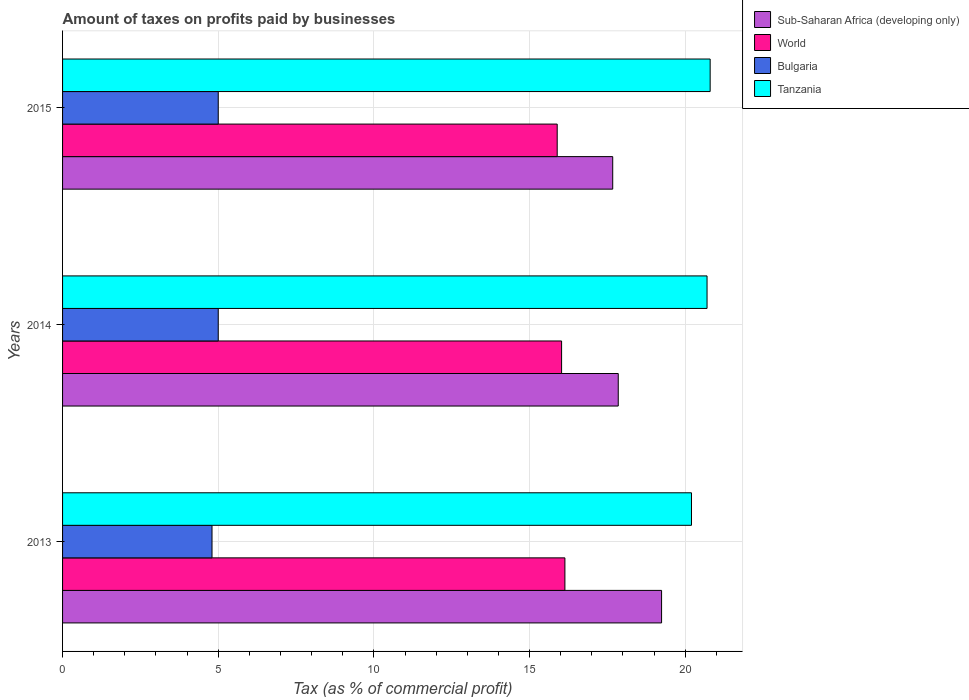Are the number of bars per tick equal to the number of legend labels?
Provide a succinct answer. Yes. How many bars are there on the 2nd tick from the top?
Keep it short and to the point. 4. How many bars are there on the 3rd tick from the bottom?
Offer a very short reply. 4. What is the label of the 1st group of bars from the top?
Ensure brevity in your answer.  2015. What is the percentage of taxes paid by businesses in Sub-Saharan Africa (developing only) in 2013?
Your answer should be very brief. 19.24. Across all years, what is the maximum percentage of taxes paid by businesses in World?
Provide a short and direct response. 16.13. Across all years, what is the minimum percentage of taxes paid by businesses in Bulgaria?
Your answer should be compact. 4.8. In which year was the percentage of taxes paid by businesses in World maximum?
Offer a terse response. 2013. In which year was the percentage of taxes paid by businesses in Sub-Saharan Africa (developing only) minimum?
Make the answer very short. 2015. What is the total percentage of taxes paid by businesses in Tanzania in the graph?
Offer a terse response. 61.7. What is the difference between the percentage of taxes paid by businesses in Bulgaria in 2013 and that in 2014?
Ensure brevity in your answer.  -0.2. What is the difference between the percentage of taxes paid by businesses in Tanzania in 2014 and the percentage of taxes paid by businesses in World in 2013?
Offer a very short reply. 4.57. What is the average percentage of taxes paid by businesses in Bulgaria per year?
Keep it short and to the point. 4.93. In the year 2015, what is the difference between the percentage of taxes paid by businesses in Sub-Saharan Africa (developing only) and percentage of taxes paid by businesses in Bulgaria?
Your response must be concise. 12.67. In how many years, is the percentage of taxes paid by businesses in Bulgaria greater than 14 %?
Provide a succinct answer. 0. What is the ratio of the percentage of taxes paid by businesses in Tanzania in 2013 to that in 2014?
Your answer should be compact. 0.98. Is the percentage of taxes paid by businesses in World in 2014 less than that in 2015?
Provide a succinct answer. No. What is the difference between the highest and the second highest percentage of taxes paid by businesses in Tanzania?
Give a very brief answer. 0.1. What is the difference between the highest and the lowest percentage of taxes paid by businesses in Sub-Saharan Africa (developing only)?
Provide a succinct answer. 1.57. Is the sum of the percentage of taxes paid by businesses in Sub-Saharan Africa (developing only) in 2013 and 2014 greater than the maximum percentage of taxes paid by businesses in World across all years?
Your response must be concise. Yes. Is it the case that in every year, the sum of the percentage of taxes paid by businesses in Bulgaria and percentage of taxes paid by businesses in Tanzania is greater than the sum of percentage of taxes paid by businesses in World and percentage of taxes paid by businesses in Sub-Saharan Africa (developing only)?
Your answer should be very brief. Yes. What does the 2nd bar from the top in 2013 represents?
Ensure brevity in your answer.  Bulgaria. Are all the bars in the graph horizontal?
Your answer should be very brief. Yes. How many years are there in the graph?
Ensure brevity in your answer.  3. Are the values on the major ticks of X-axis written in scientific E-notation?
Your answer should be very brief. No. Does the graph contain any zero values?
Provide a short and direct response. No. How are the legend labels stacked?
Offer a terse response. Vertical. What is the title of the graph?
Your response must be concise. Amount of taxes on profits paid by businesses. What is the label or title of the X-axis?
Your response must be concise. Tax (as % of commercial profit). What is the Tax (as % of commercial profit) of Sub-Saharan Africa (developing only) in 2013?
Your response must be concise. 19.24. What is the Tax (as % of commercial profit) in World in 2013?
Provide a succinct answer. 16.13. What is the Tax (as % of commercial profit) of Tanzania in 2013?
Give a very brief answer. 20.2. What is the Tax (as % of commercial profit) in Sub-Saharan Africa (developing only) in 2014?
Provide a succinct answer. 17.85. What is the Tax (as % of commercial profit) in World in 2014?
Provide a succinct answer. 16.03. What is the Tax (as % of commercial profit) of Tanzania in 2014?
Your answer should be compact. 20.7. What is the Tax (as % of commercial profit) in Sub-Saharan Africa (developing only) in 2015?
Give a very brief answer. 17.67. What is the Tax (as % of commercial profit) in World in 2015?
Your answer should be compact. 15.89. What is the Tax (as % of commercial profit) of Tanzania in 2015?
Keep it short and to the point. 20.8. Across all years, what is the maximum Tax (as % of commercial profit) in Sub-Saharan Africa (developing only)?
Provide a short and direct response. 19.24. Across all years, what is the maximum Tax (as % of commercial profit) of World?
Offer a terse response. 16.13. Across all years, what is the maximum Tax (as % of commercial profit) in Tanzania?
Provide a succinct answer. 20.8. Across all years, what is the minimum Tax (as % of commercial profit) of Sub-Saharan Africa (developing only)?
Make the answer very short. 17.67. Across all years, what is the minimum Tax (as % of commercial profit) in World?
Your answer should be very brief. 15.89. Across all years, what is the minimum Tax (as % of commercial profit) of Bulgaria?
Your response must be concise. 4.8. Across all years, what is the minimum Tax (as % of commercial profit) in Tanzania?
Your answer should be very brief. 20.2. What is the total Tax (as % of commercial profit) of Sub-Saharan Africa (developing only) in the graph?
Give a very brief answer. 54.76. What is the total Tax (as % of commercial profit) in World in the graph?
Offer a very short reply. 48.05. What is the total Tax (as % of commercial profit) of Tanzania in the graph?
Your answer should be very brief. 61.7. What is the difference between the Tax (as % of commercial profit) in Sub-Saharan Africa (developing only) in 2013 and that in 2014?
Ensure brevity in your answer.  1.39. What is the difference between the Tax (as % of commercial profit) of World in 2013 and that in 2014?
Your answer should be compact. 0.11. What is the difference between the Tax (as % of commercial profit) in Tanzania in 2013 and that in 2014?
Provide a short and direct response. -0.5. What is the difference between the Tax (as % of commercial profit) of Sub-Saharan Africa (developing only) in 2013 and that in 2015?
Offer a very short reply. 1.57. What is the difference between the Tax (as % of commercial profit) in World in 2013 and that in 2015?
Make the answer very short. 0.25. What is the difference between the Tax (as % of commercial profit) of Sub-Saharan Africa (developing only) in 2014 and that in 2015?
Give a very brief answer. 0.18. What is the difference between the Tax (as % of commercial profit) in World in 2014 and that in 2015?
Your answer should be very brief. 0.14. What is the difference between the Tax (as % of commercial profit) of Bulgaria in 2014 and that in 2015?
Keep it short and to the point. 0. What is the difference between the Tax (as % of commercial profit) in Tanzania in 2014 and that in 2015?
Offer a very short reply. -0.1. What is the difference between the Tax (as % of commercial profit) of Sub-Saharan Africa (developing only) in 2013 and the Tax (as % of commercial profit) of World in 2014?
Ensure brevity in your answer.  3.21. What is the difference between the Tax (as % of commercial profit) in Sub-Saharan Africa (developing only) in 2013 and the Tax (as % of commercial profit) in Bulgaria in 2014?
Ensure brevity in your answer.  14.24. What is the difference between the Tax (as % of commercial profit) in Sub-Saharan Africa (developing only) in 2013 and the Tax (as % of commercial profit) in Tanzania in 2014?
Your answer should be very brief. -1.46. What is the difference between the Tax (as % of commercial profit) in World in 2013 and the Tax (as % of commercial profit) in Bulgaria in 2014?
Your answer should be compact. 11.13. What is the difference between the Tax (as % of commercial profit) of World in 2013 and the Tax (as % of commercial profit) of Tanzania in 2014?
Your response must be concise. -4.57. What is the difference between the Tax (as % of commercial profit) in Bulgaria in 2013 and the Tax (as % of commercial profit) in Tanzania in 2014?
Offer a very short reply. -15.9. What is the difference between the Tax (as % of commercial profit) of Sub-Saharan Africa (developing only) in 2013 and the Tax (as % of commercial profit) of World in 2015?
Your answer should be compact. 3.35. What is the difference between the Tax (as % of commercial profit) of Sub-Saharan Africa (developing only) in 2013 and the Tax (as % of commercial profit) of Bulgaria in 2015?
Provide a short and direct response. 14.24. What is the difference between the Tax (as % of commercial profit) of Sub-Saharan Africa (developing only) in 2013 and the Tax (as % of commercial profit) of Tanzania in 2015?
Your answer should be compact. -1.56. What is the difference between the Tax (as % of commercial profit) of World in 2013 and the Tax (as % of commercial profit) of Bulgaria in 2015?
Your answer should be compact. 11.13. What is the difference between the Tax (as % of commercial profit) in World in 2013 and the Tax (as % of commercial profit) in Tanzania in 2015?
Keep it short and to the point. -4.67. What is the difference between the Tax (as % of commercial profit) in Bulgaria in 2013 and the Tax (as % of commercial profit) in Tanzania in 2015?
Keep it short and to the point. -16. What is the difference between the Tax (as % of commercial profit) of Sub-Saharan Africa (developing only) in 2014 and the Tax (as % of commercial profit) of World in 2015?
Offer a very short reply. 1.96. What is the difference between the Tax (as % of commercial profit) in Sub-Saharan Africa (developing only) in 2014 and the Tax (as % of commercial profit) in Bulgaria in 2015?
Offer a terse response. 12.85. What is the difference between the Tax (as % of commercial profit) in Sub-Saharan Africa (developing only) in 2014 and the Tax (as % of commercial profit) in Tanzania in 2015?
Your answer should be compact. -2.95. What is the difference between the Tax (as % of commercial profit) of World in 2014 and the Tax (as % of commercial profit) of Bulgaria in 2015?
Your response must be concise. 11.03. What is the difference between the Tax (as % of commercial profit) in World in 2014 and the Tax (as % of commercial profit) in Tanzania in 2015?
Make the answer very short. -4.77. What is the difference between the Tax (as % of commercial profit) of Bulgaria in 2014 and the Tax (as % of commercial profit) of Tanzania in 2015?
Your answer should be compact. -15.8. What is the average Tax (as % of commercial profit) in Sub-Saharan Africa (developing only) per year?
Provide a short and direct response. 18.25. What is the average Tax (as % of commercial profit) in World per year?
Make the answer very short. 16.02. What is the average Tax (as % of commercial profit) of Bulgaria per year?
Your answer should be compact. 4.93. What is the average Tax (as % of commercial profit) in Tanzania per year?
Ensure brevity in your answer.  20.57. In the year 2013, what is the difference between the Tax (as % of commercial profit) of Sub-Saharan Africa (developing only) and Tax (as % of commercial profit) of World?
Your answer should be very brief. 3.11. In the year 2013, what is the difference between the Tax (as % of commercial profit) in Sub-Saharan Africa (developing only) and Tax (as % of commercial profit) in Bulgaria?
Give a very brief answer. 14.44. In the year 2013, what is the difference between the Tax (as % of commercial profit) of Sub-Saharan Africa (developing only) and Tax (as % of commercial profit) of Tanzania?
Keep it short and to the point. -0.96. In the year 2013, what is the difference between the Tax (as % of commercial profit) of World and Tax (as % of commercial profit) of Bulgaria?
Make the answer very short. 11.33. In the year 2013, what is the difference between the Tax (as % of commercial profit) in World and Tax (as % of commercial profit) in Tanzania?
Make the answer very short. -4.07. In the year 2013, what is the difference between the Tax (as % of commercial profit) of Bulgaria and Tax (as % of commercial profit) of Tanzania?
Provide a short and direct response. -15.4. In the year 2014, what is the difference between the Tax (as % of commercial profit) of Sub-Saharan Africa (developing only) and Tax (as % of commercial profit) of World?
Provide a short and direct response. 1.82. In the year 2014, what is the difference between the Tax (as % of commercial profit) of Sub-Saharan Africa (developing only) and Tax (as % of commercial profit) of Bulgaria?
Offer a very short reply. 12.85. In the year 2014, what is the difference between the Tax (as % of commercial profit) in Sub-Saharan Africa (developing only) and Tax (as % of commercial profit) in Tanzania?
Offer a very short reply. -2.85. In the year 2014, what is the difference between the Tax (as % of commercial profit) of World and Tax (as % of commercial profit) of Bulgaria?
Give a very brief answer. 11.03. In the year 2014, what is the difference between the Tax (as % of commercial profit) of World and Tax (as % of commercial profit) of Tanzania?
Provide a short and direct response. -4.67. In the year 2014, what is the difference between the Tax (as % of commercial profit) of Bulgaria and Tax (as % of commercial profit) of Tanzania?
Offer a terse response. -15.7. In the year 2015, what is the difference between the Tax (as % of commercial profit) of Sub-Saharan Africa (developing only) and Tax (as % of commercial profit) of World?
Provide a short and direct response. 1.78. In the year 2015, what is the difference between the Tax (as % of commercial profit) in Sub-Saharan Africa (developing only) and Tax (as % of commercial profit) in Bulgaria?
Offer a terse response. 12.67. In the year 2015, what is the difference between the Tax (as % of commercial profit) in Sub-Saharan Africa (developing only) and Tax (as % of commercial profit) in Tanzania?
Your answer should be very brief. -3.13. In the year 2015, what is the difference between the Tax (as % of commercial profit) in World and Tax (as % of commercial profit) in Bulgaria?
Your answer should be compact. 10.89. In the year 2015, what is the difference between the Tax (as % of commercial profit) in World and Tax (as % of commercial profit) in Tanzania?
Provide a short and direct response. -4.91. In the year 2015, what is the difference between the Tax (as % of commercial profit) in Bulgaria and Tax (as % of commercial profit) in Tanzania?
Offer a terse response. -15.8. What is the ratio of the Tax (as % of commercial profit) in Sub-Saharan Africa (developing only) in 2013 to that in 2014?
Offer a very short reply. 1.08. What is the ratio of the Tax (as % of commercial profit) of World in 2013 to that in 2014?
Ensure brevity in your answer.  1.01. What is the ratio of the Tax (as % of commercial profit) of Tanzania in 2013 to that in 2014?
Provide a succinct answer. 0.98. What is the ratio of the Tax (as % of commercial profit) in Sub-Saharan Africa (developing only) in 2013 to that in 2015?
Offer a very short reply. 1.09. What is the ratio of the Tax (as % of commercial profit) of World in 2013 to that in 2015?
Your answer should be very brief. 1.02. What is the ratio of the Tax (as % of commercial profit) of Bulgaria in 2013 to that in 2015?
Offer a terse response. 0.96. What is the ratio of the Tax (as % of commercial profit) in Tanzania in 2013 to that in 2015?
Make the answer very short. 0.97. What is the ratio of the Tax (as % of commercial profit) in World in 2014 to that in 2015?
Your answer should be very brief. 1.01. What is the ratio of the Tax (as % of commercial profit) in Tanzania in 2014 to that in 2015?
Make the answer very short. 1. What is the difference between the highest and the second highest Tax (as % of commercial profit) in Sub-Saharan Africa (developing only)?
Ensure brevity in your answer.  1.39. What is the difference between the highest and the second highest Tax (as % of commercial profit) of World?
Offer a very short reply. 0.11. What is the difference between the highest and the second highest Tax (as % of commercial profit) of Bulgaria?
Make the answer very short. 0. What is the difference between the highest and the second highest Tax (as % of commercial profit) of Tanzania?
Your response must be concise. 0.1. What is the difference between the highest and the lowest Tax (as % of commercial profit) in Sub-Saharan Africa (developing only)?
Make the answer very short. 1.57. What is the difference between the highest and the lowest Tax (as % of commercial profit) of World?
Your response must be concise. 0.25. What is the difference between the highest and the lowest Tax (as % of commercial profit) of Tanzania?
Make the answer very short. 0.6. 